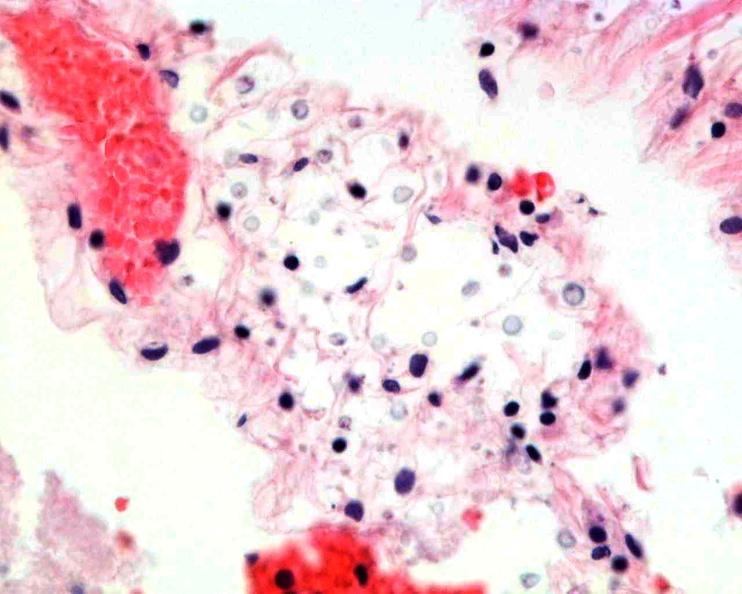what is present?
Answer the question using a single word or phrase. Nervous 